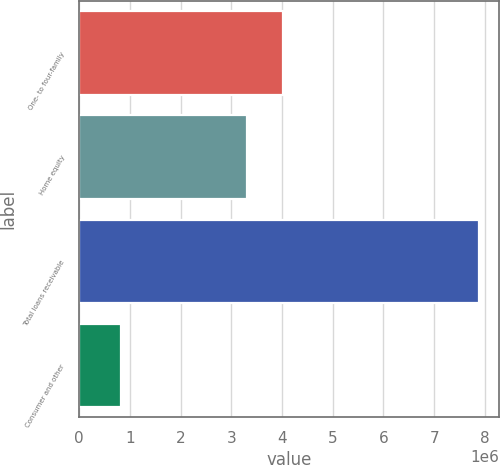Convert chart to OTSL. <chart><loc_0><loc_0><loc_500><loc_500><bar_chart><fcel>One- to four-family<fcel>Home equity<fcel>Total loans receivable<fcel>Consumer and other<nl><fcel>4.01562e+06<fcel>3.30915e+06<fcel>7.88418e+06<fcel>819468<nl></chart> 